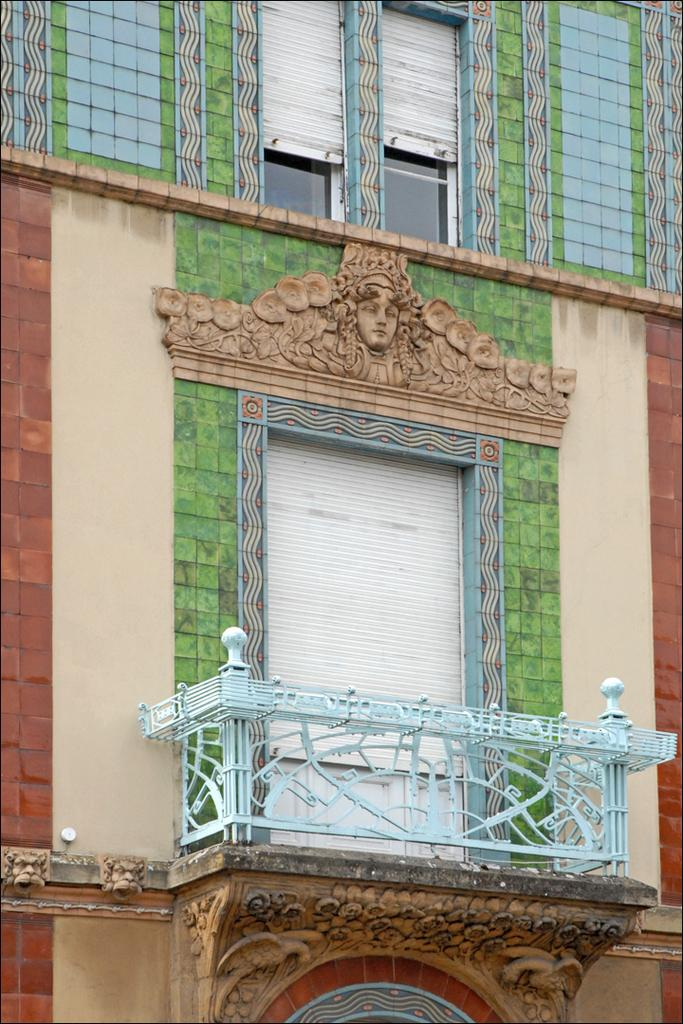What structure is attached to the wall in the image? There is a shelter on the wall in the image. How many windows are present on the top of the wall in the image? There are two windows on the top of the wall in the image. What type of window covering is visible in the image? There is a window blind in the image. What can be seen on the right side of the image? There is a building visible on the right side of the image. Can you tell me how many verses are written on the rake in the image? There is no rake or verses present in the image. What type of ocean can be seen in the image? There is no ocean present in the image. 